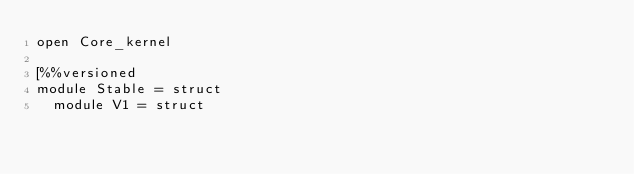Convert code to text. <code><loc_0><loc_0><loc_500><loc_500><_OCaml_>open Core_kernel

[%%versioned
module Stable = struct
  module V1 = struct</code> 